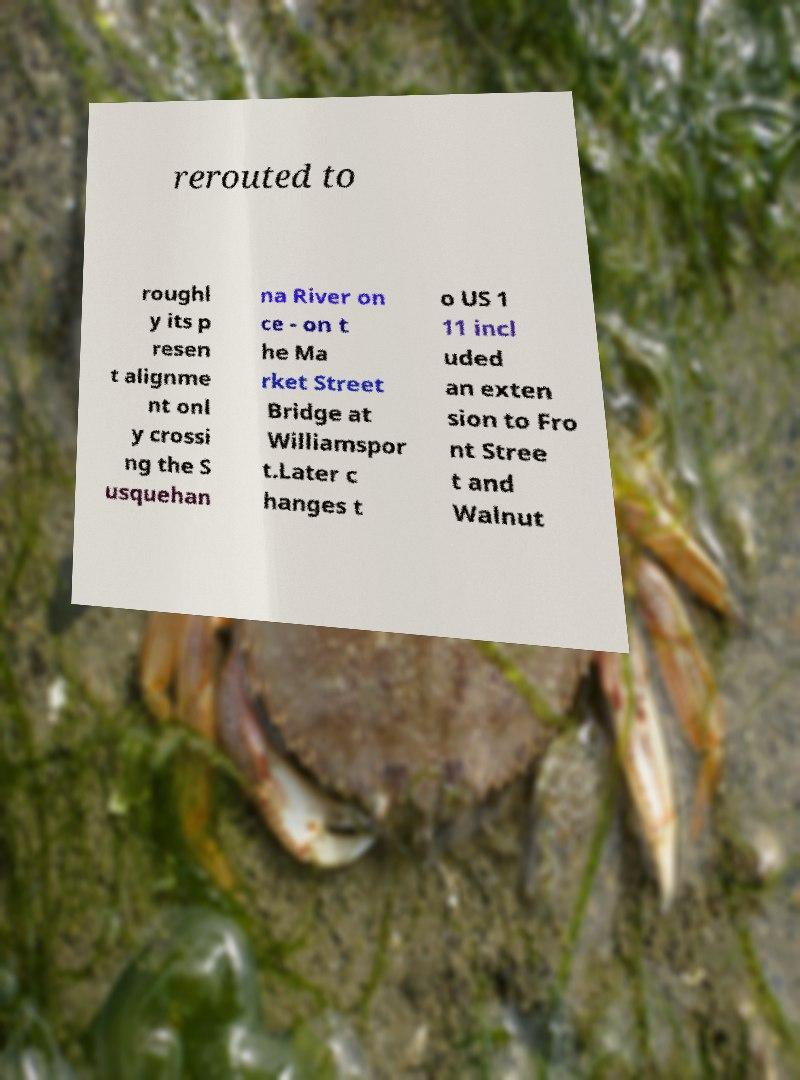Please identify and transcribe the text found in this image. rerouted to roughl y its p resen t alignme nt onl y crossi ng the S usquehan na River on ce - on t he Ma rket Street Bridge at Williamspor t.Later c hanges t o US 1 11 incl uded an exten sion to Fro nt Stree t and Walnut 